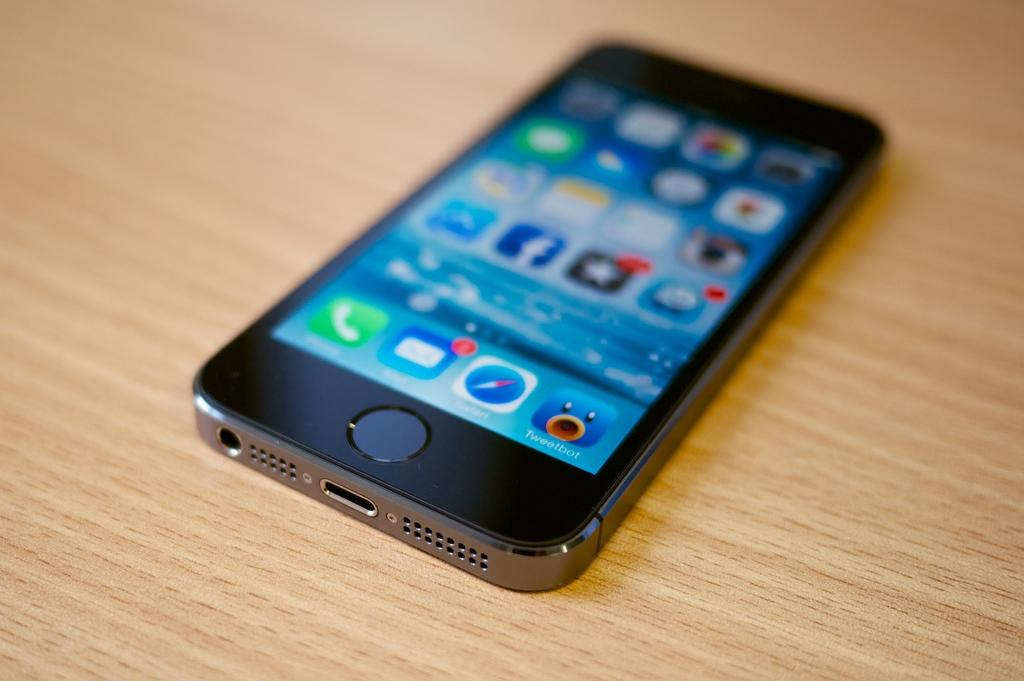<image>
Summarize the visual content of the image. A smart phone laying face up showing apps such as facebook. 